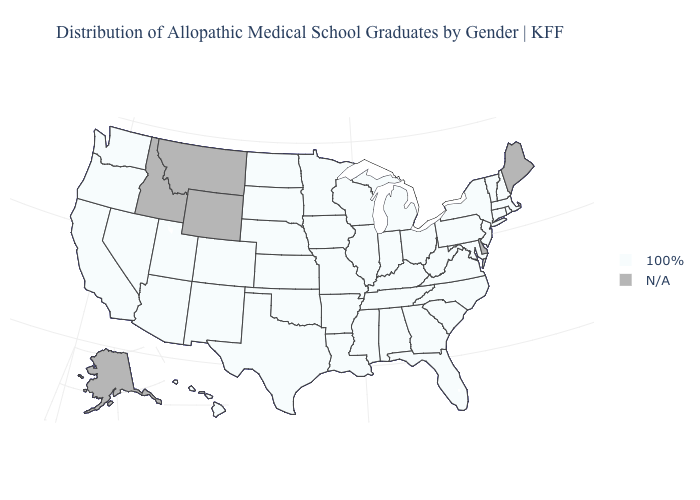Which states have the lowest value in the MidWest?
Keep it brief. Illinois, Indiana, Iowa, Kansas, Michigan, Minnesota, Missouri, Nebraska, North Dakota, Ohio, South Dakota, Wisconsin. What is the value of South Dakota?
Quick response, please. 100%. What is the lowest value in states that border Louisiana?
Answer briefly. 100%. Which states have the lowest value in the West?
Keep it brief. Arizona, California, Colorado, Hawaii, Nevada, New Mexico, Oregon, Utah, Washington. What is the lowest value in the West?
Give a very brief answer. 100%. What is the lowest value in states that border Arkansas?
Answer briefly. 100%. What is the value of Minnesota?
Be succinct. 100%. What is the value of Kentucky?
Keep it brief. 100%. Does the map have missing data?
Keep it brief. Yes. What is the value of Illinois?
Concise answer only. 100%. 